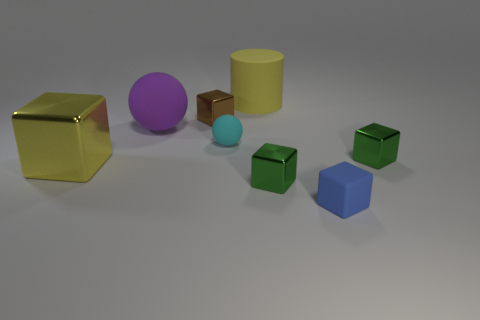Subtract 1 blocks. How many blocks are left? 4 Subtract all blue cubes. How many cubes are left? 4 Subtract all tiny brown cubes. How many cubes are left? 4 Subtract all cyan cubes. Subtract all brown cylinders. How many cubes are left? 5 Add 1 tiny brown cubes. How many objects exist? 9 Subtract all cylinders. How many objects are left? 7 Subtract 0 cyan cylinders. How many objects are left? 8 Subtract all blue blocks. Subtract all big rubber things. How many objects are left? 5 Add 5 yellow matte objects. How many yellow matte objects are left? 6 Add 1 brown metallic objects. How many brown metallic objects exist? 2 